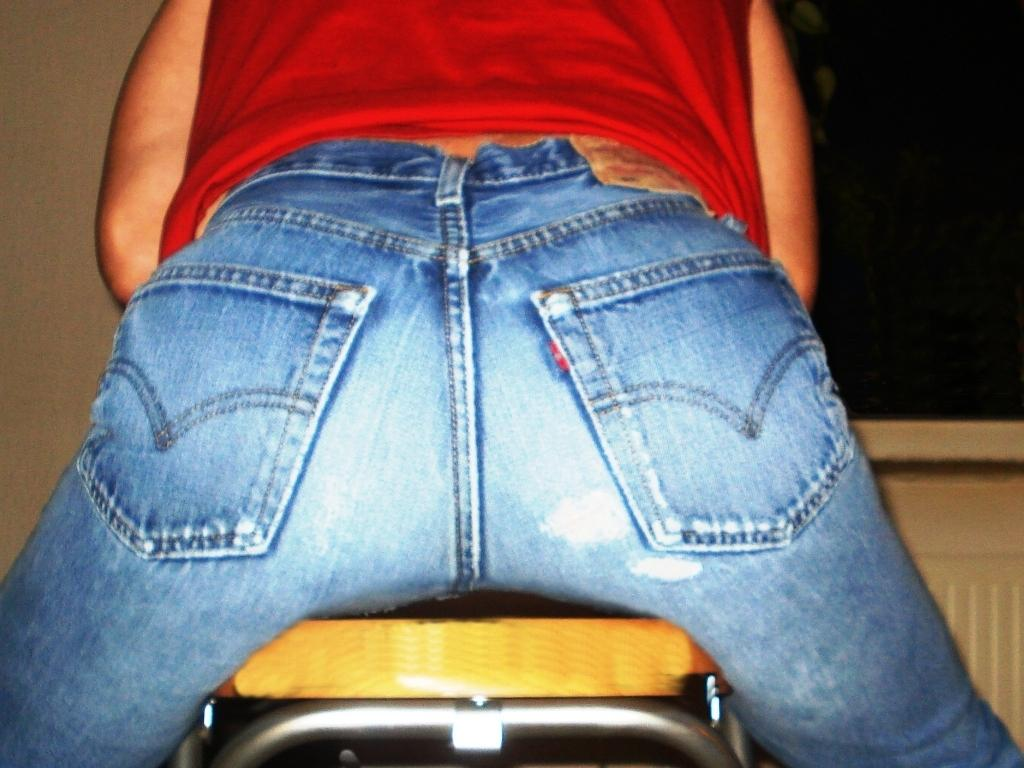What is the main subject of the image? There is a person in the image. What type of clothing is the person wearing? The person is wearing blue jeans and a red color top. What can be seen in the background of the image? There is a wall and an object in the background of the image. What type of suit is the person wearing in the image? There is no suit visible in the image; the person is wearing blue jeans and a red color top. What observation can be made about the person's interaction with the wall in the image? There is no interaction between the person and the wall depicted in the image. 